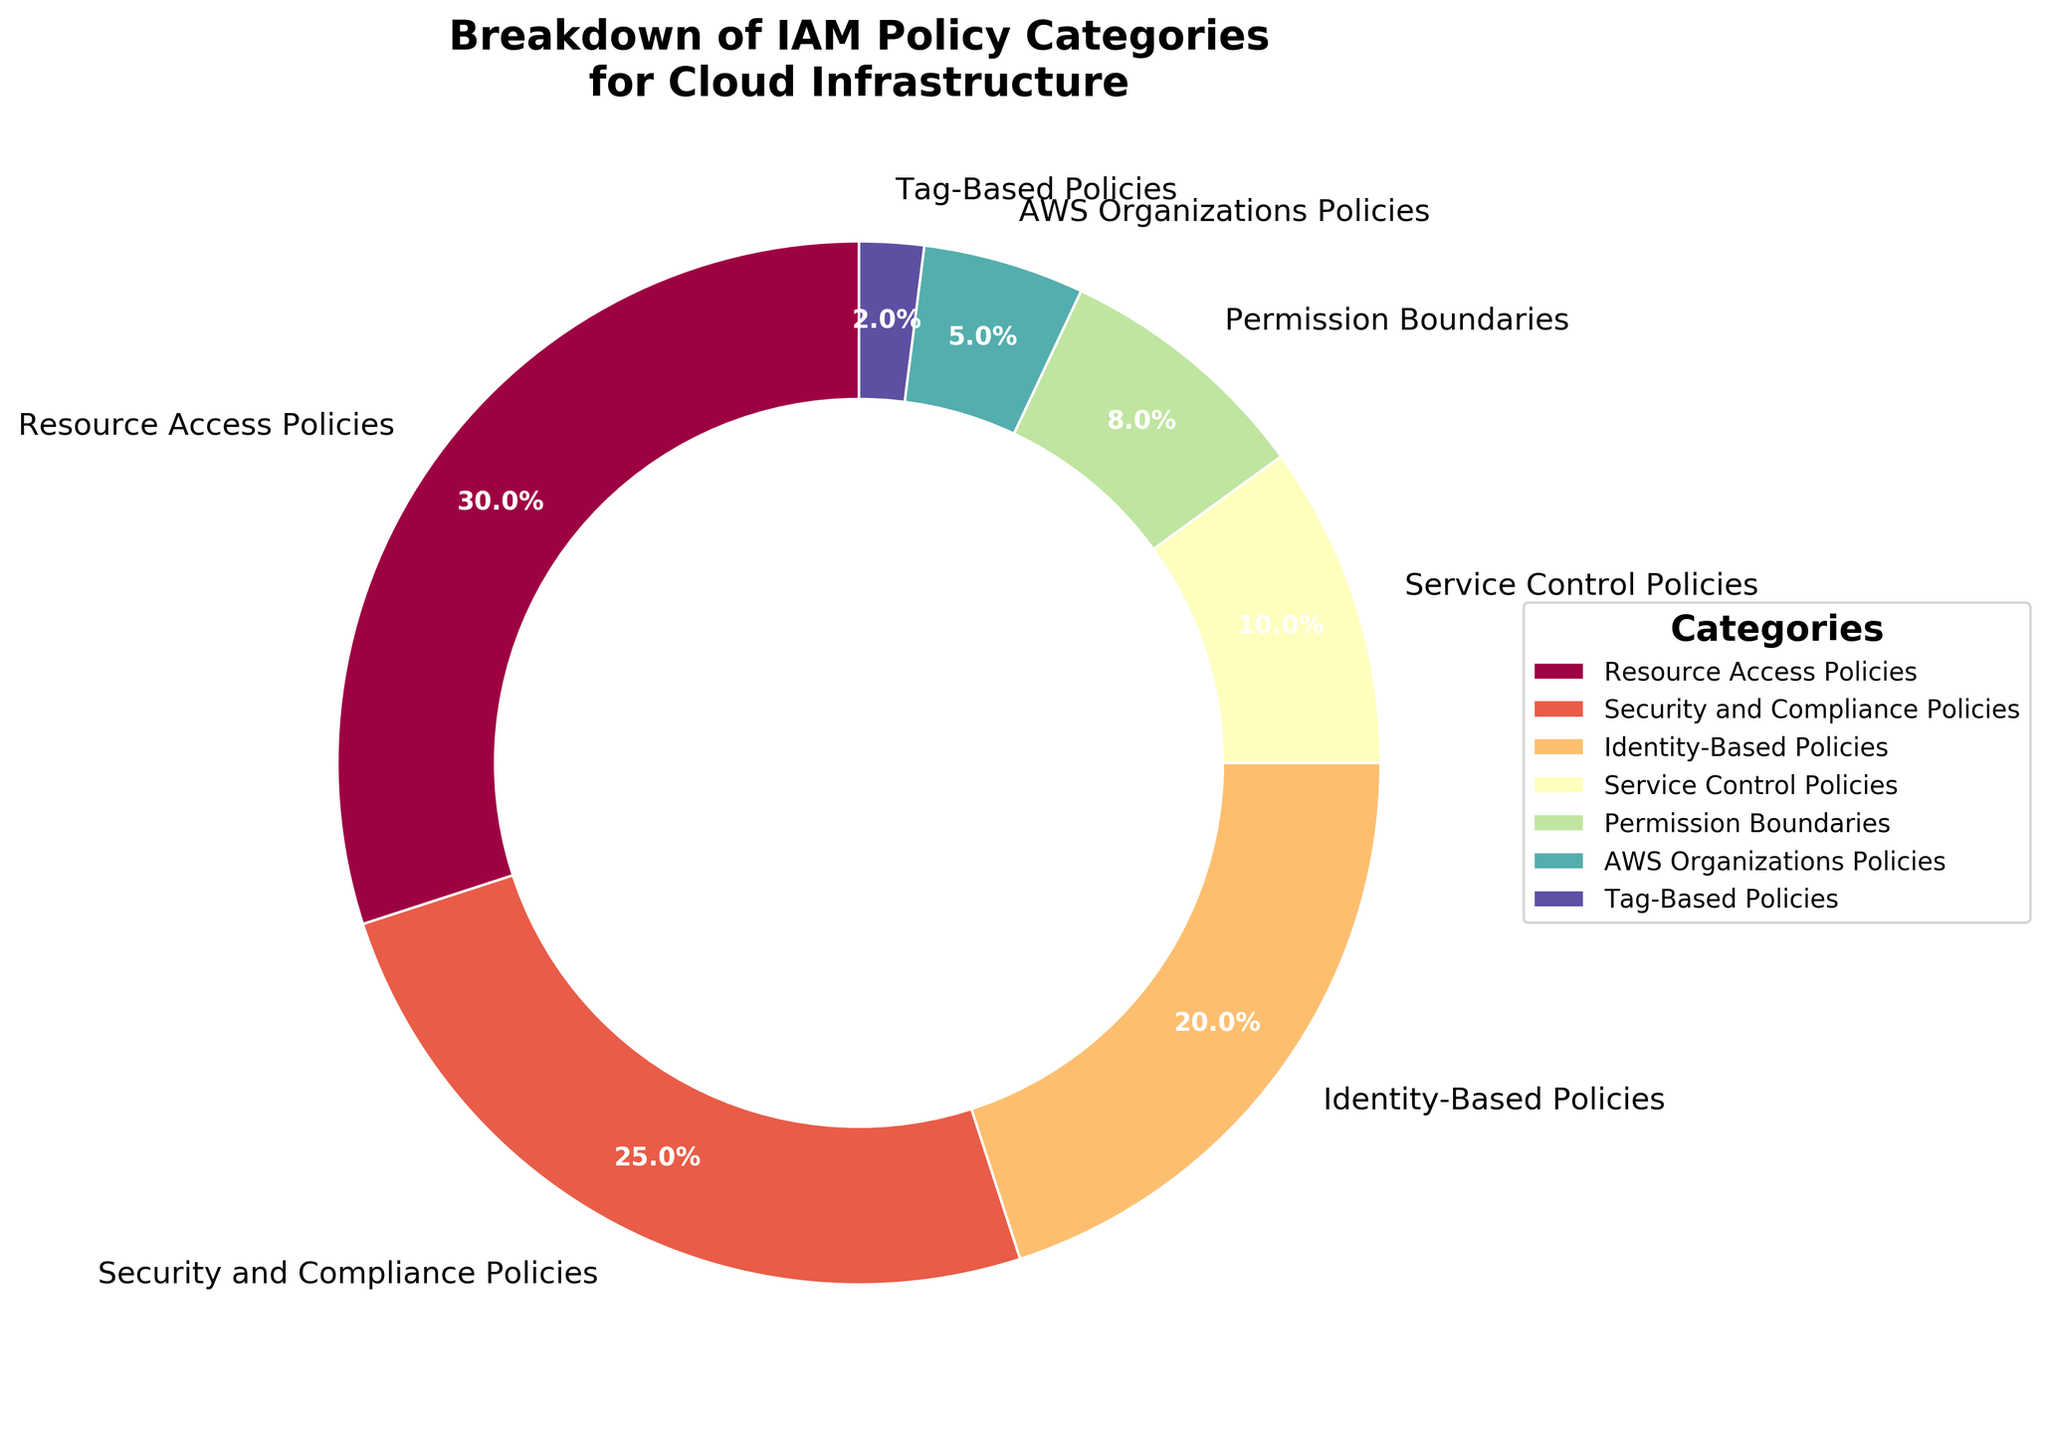What percentage of IAM policies are resource access policies? Refer to the figure's pie chart and identify the segment labeled "Resource Access Policies," which shows the corresponding percentage.
Answer: 30% Which IAM policy category has the lowest percentage? Look at all the segments and labels in the pie chart and identify the one with the smallest percentage.
Answer: Tag-Based Policies What is the combined percentage of Security and Compliance Policies and Identity-Based Policies? Add the percentages of Security and Compliance Policies (25%) and Identity-Based Policies (20%) from the pie chart. 25 + 20 = 45
Answer: 45% How much more percentage do Resource Access Policies have compared to Service Control Policies? Subtract the percentage of Service Control Policies (10%) from that of Resource Access Policies (30%). 30 - 10 = 20
Answer: 20% Which policy category constitutes one-tenth of the total IAM policies? Identify from the pie chart the category labeled with 10%, which corresponds to one-tenth of the total percentage.
Answer: Service Control Policies If you combine Permission Boundaries and AWS Organizations Policies, what percentage do they make up together? Add the percentages of Permission Boundaries (8%) and AWS Organizations Policies (5%) from the pie chart. 8 + 5 = 13
Answer: 13% Compare the percentage of Identity-Based Policies to that of Security and Compliance Policies. Which one is higher? Observe the segments of the pie chart representing Identity-Based Policies (20%) and Security and Compliance Policies (25%). 25% is greater than 20%
Answer: Security and Compliance Policies What percentage of the IAM policies fall under categories other than Resource Access Policies and Security and Compliance Policies? Add the percentages of all categories other than Resource Access Policies (30%) and Security and Compliance Policies (25%). Remaining are (20 + 10 + 8 + 5 + 2). Summing them up: 20 + 10 + 8 + 5 + 2 = 45
Answer: 45% What color represents the Permission Boundaries segment in the pie chart? Look at the visual and identify the color used to fill the segment labeled "Permission Boundaries." As exact color codes are unseen, general color like a shade might be noted.
Answer: [The color can be determined from the visual and noted here, e.g., a shade from the Spectral colormap] 